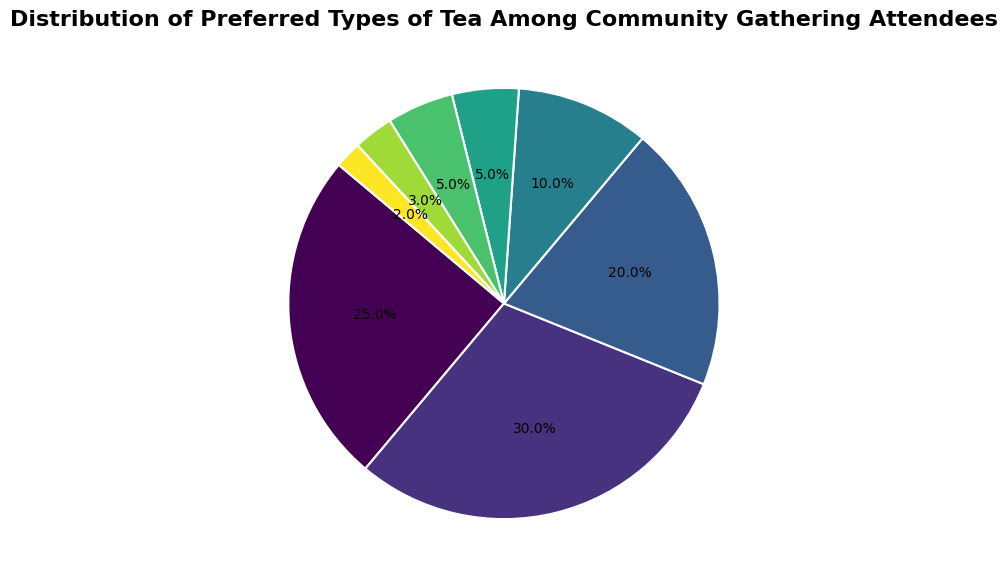What type of tea is the most preferred among community gathering attendees? By looking at the largest segment of the pie chart, we observe that Black Tea occupies the most space. The percentage label for Black Tea is 30%, which is the highest percentage among all types.
Answer: Black Tea What is the combined percentage of Green Tea and Herbal Tea preferences? The percentage of Green Tea is 25%, and the percentage of Herbal Tea is 20%. Summing these values gives 25% + 20% = 45%.
Answer: 45% Which type of tea is more preferred, Chai Tea or White Tea? By comparing the size and percentage values of the segments, Chai Tea has a preference of 5% and White Tea also has a preference of 5%. Therefore, they are equally preferred.
Answer: Equal What is the difference in preference percentage between Green Tea and Oolong Tea? The percentage preference for Green Tea is 25% and for Oolong Tea is 10%. The difference is calculated as 25% - 10% = 15%.
Answer: 15% What is the percentage of attendees who prefer teas other than Black Tea and Green Tea? First, sum the percentages of Black Tea and Green Tea: 30% + 25% = 55%. The total preference is 100%, so the attendees who prefer other teas represent 100% - 55% = 45%.
Answer: 45% How much more popular is Black Tea compared to Matcha? The percentage for Black Tea is 30%, and for Matcha, it is 3%. Subtracting these gives us 30% - 3% = 27%.
Answer: 27% What type of tea has the smallest preference, and what is the percentage? The smallest segment in the pie chart corresponds to the 'Others' category, which shows a preference of 2%.
Answer: Others, 2% Which types of tea together make up less than 10% of the total preference? The segments for Matcha, Others, Chai Tea, and White Tea individually show 3%, 2%, 5%, and 5% respectively. Each value is less than 10%.
Answer: Matcha, Others, Chai Tea, White Tea Are there more attendees who prefer Herbal Tea or Oolong Tea? The preference percentage for Herbal Tea is 20%, whereas for Oolong Tea it is 10%. Therefore, Herbal Tea has a higher preference.
Answer: Herbal Tea 